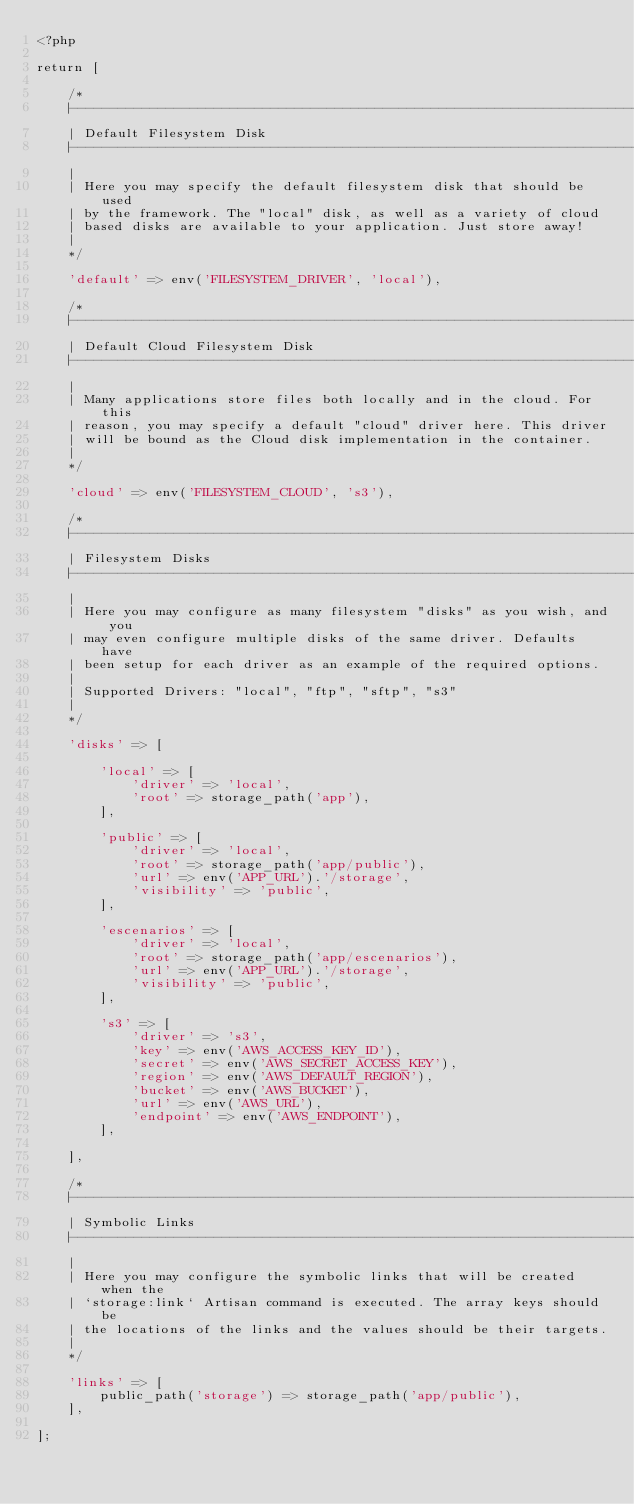Convert code to text. <code><loc_0><loc_0><loc_500><loc_500><_PHP_><?php

return [

    /*
    |--------------------------------------------------------------------------
    | Default Filesystem Disk
    |--------------------------------------------------------------------------
    |
    | Here you may specify the default filesystem disk that should be used
    | by the framework. The "local" disk, as well as a variety of cloud
    | based disks are available to your application. Just store away!
    |
    */

    'default' => env('FILESYSTEM_DRIVER', 'local'),

    /*
    |--------------------------------------------------------------------------
    | Default Cloud Filesystem Disk
    |--------------------------------------------------------------------------
    |
    | Many applications store files both locally and in the cloud. For this
    | reason, you may specify a default "cloud" driver here. This driver
    | will be bound as the Cloud disk implementation in the container.
    |
    */

    'cloud' => env('FILESYSTEM_CLOUD', 's3'),

    /*
    |--------------------------------------------------------------------------
    | Filesystem Disks
    |--------------------------------------------------------------------------
    |
    | Here you may configure as many filesystem "disks" as you wish, and you
    | may even configure multiple disks of the same driver. Defaults have
    | been setup for each driver as an example of the required options.
    |
    | Supported Drivers: "local", "ftp", "sftp", "s3"
    |
    */

    'disks' => [

        'local' => [
            'driver' => 'local',
            'root' => storage_path('app'),
        ],

        'public' => [
            'driver' => 'local',
            'root' => storage_path('app/public'),
            'url' => env('APP_URL').'/storage',
            'visibility' => 'public',
        ],

        'escenarios' => [
            'driver' => 'local',
            'root' => storage_path('app/escenarios'),
            'url' => env('APP_URL').'/storage',
            'visibility' => 'public',
        ],

        's3' => [
            'driver' => 's3',
            'key' => env('AWS_ACCESS_KEY_ID'),
            'secret' => env('AWS_SECRET_ACCESS_KEY'),
            'region' => env('AWS_DEFAULT_REGION'),
            'bucket' => env('AWS_BUCKET'),
            'url' => env('AWS_URL'),
            'endpoint' => env('AWS_ENDPOINT'),
        ],

    ],

    /*
    |--------------------------------------------------------------------------
    | Symbolic Links
    |--------------------------------------------------------------------------
    |
    | Here you may configure the symbolic links that will be created when the
    | `storage:link` Artisan command is executed. The array keys should be
    | the locations of the links and the values should be their targets.
    |
    */

    'links' => [
        public_path('storage') => storage_path('app/public'),
    ],

];
</code> 